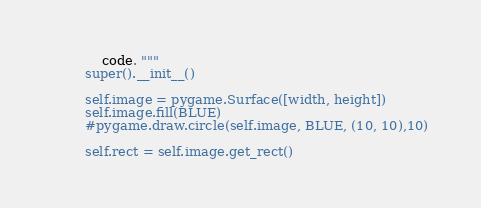Convert code to text. <code><loc_0><loc_0><loc_500><loc_500><_Python_>            code. """
        super().__init__()

        self.image = pygame.Surface([width, height])
        self.image.fill(BLUE)
        #pygame.draw.circle(self.image, BLUE, (10, 10),10)

        self.rect = self.image.get_rect()</code> 